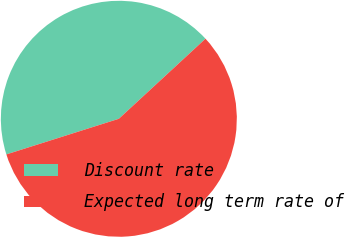<chart> <loc_0><loc_0><loc_500><loc_500><pie_chart><fcel>Discount rate<fcel>Expected long term rate of<nl><fcel>43.01%<fcel>56.99%<nl></chart> 